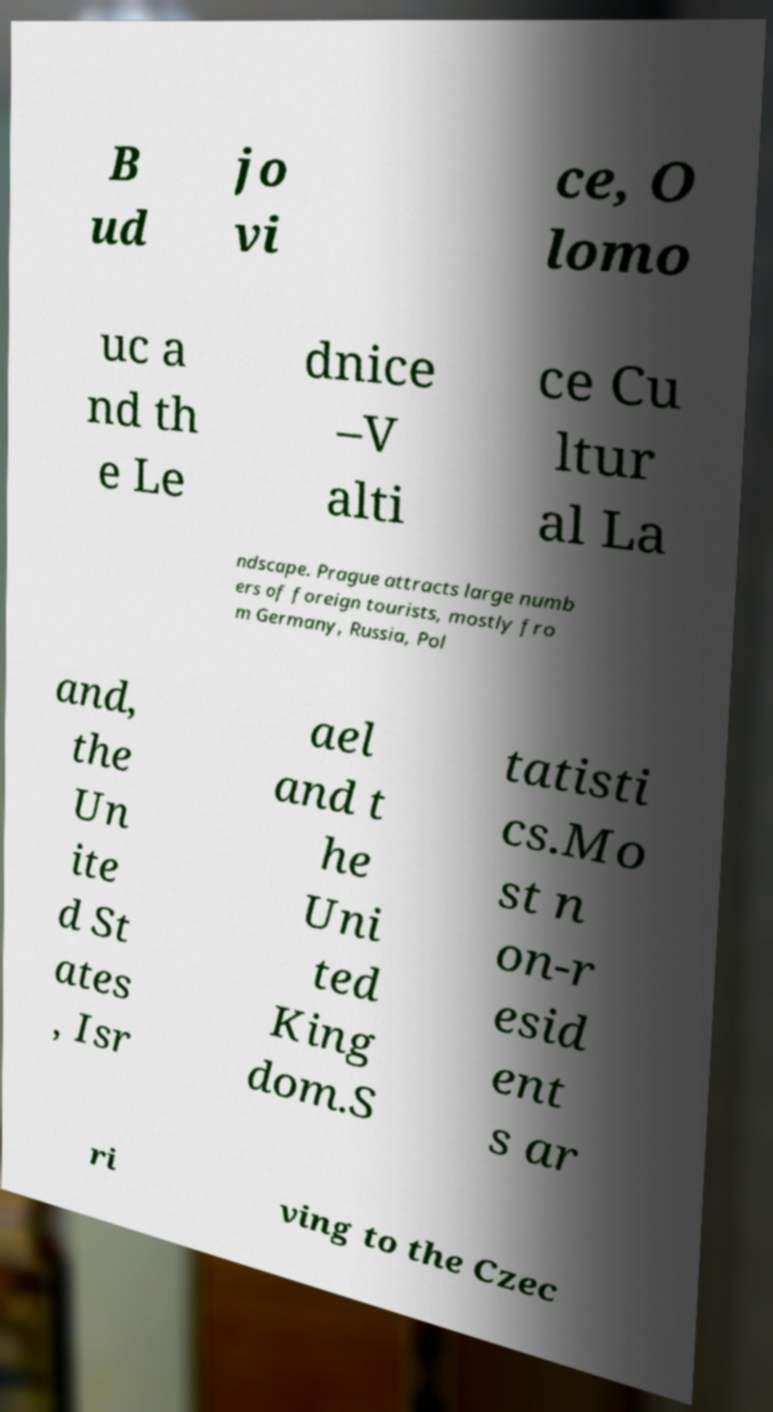Could you assist in decoding the text presented in this image and type it out clearly? B ud jo vi ce, O lomo uc a nd th e Le dnice –V alti ce Cu ltur al La ndscape. Prague attracts large numb ers of foreign tourists, mostly fro m Germany, Russia, Pol and, the Un ite d St ates , Isr ael and t he Uni ted King dom.S tatisti cs.Mo st n on-r esid ent s ar ri ving to the Czec 